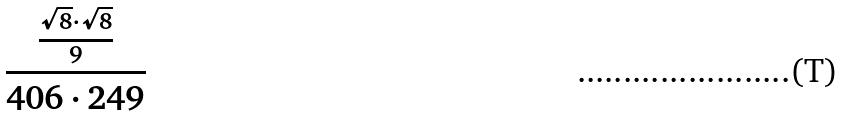Convert formula to latex. <formula><loc_0><loc_0><loc_500><loc_500>\frac { \frac { \sqrt { 8 } \cdot \sqrt { 8 } } { 9 } } { 4 0 6 \cdot 2 4 9 }</formula> 